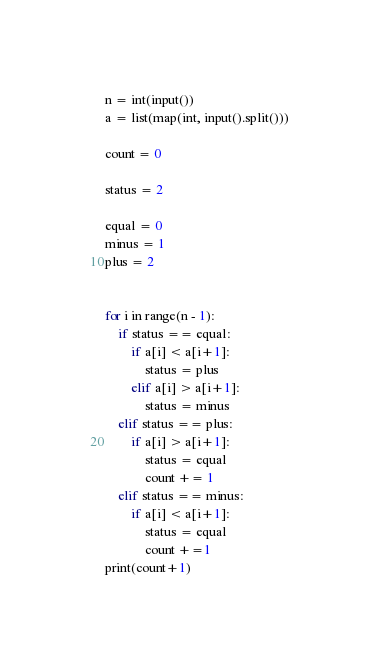<code> <loc_0><loc_0><loc_500><loc_500><_Python_>n = int(input())
a = list(map(int, input().split()))

count = 0

status = 2

equal = 0
minus = 1
plus = 2


for i in range(n - 1):
    if status == equal:
        if a[i] < a[i+1]:
            status = plus
        elif a[i] > a[i+1]:
            status = minus 
    elif status == plus:
        if a[i] > a[i+1]:
            status = equal
            count += 1
    elif status == minus:
        if a[i] < a[i+1]:
            status = equal
            count +=1
print(count+1)

</code> 